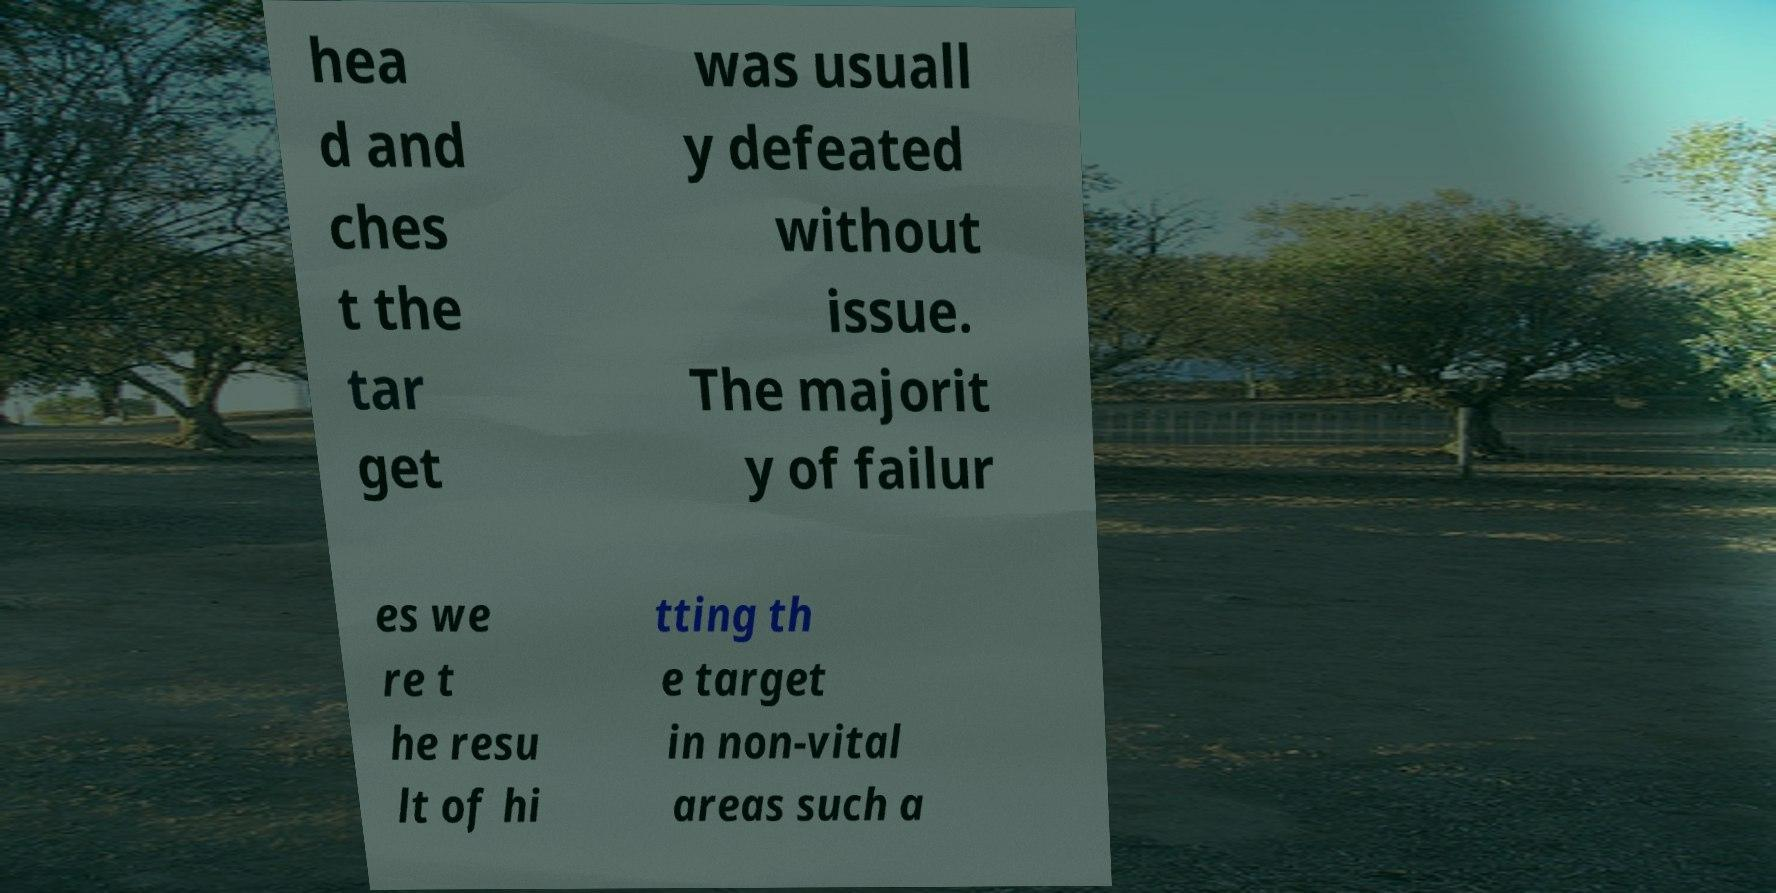Please read and relay the text visible in this image. What does it say? hea d and ches t the tar get was usuall y defeated without issue. The majorit y of failur es we re t he resu lt of hi tting th e target in non-vital areas such a 